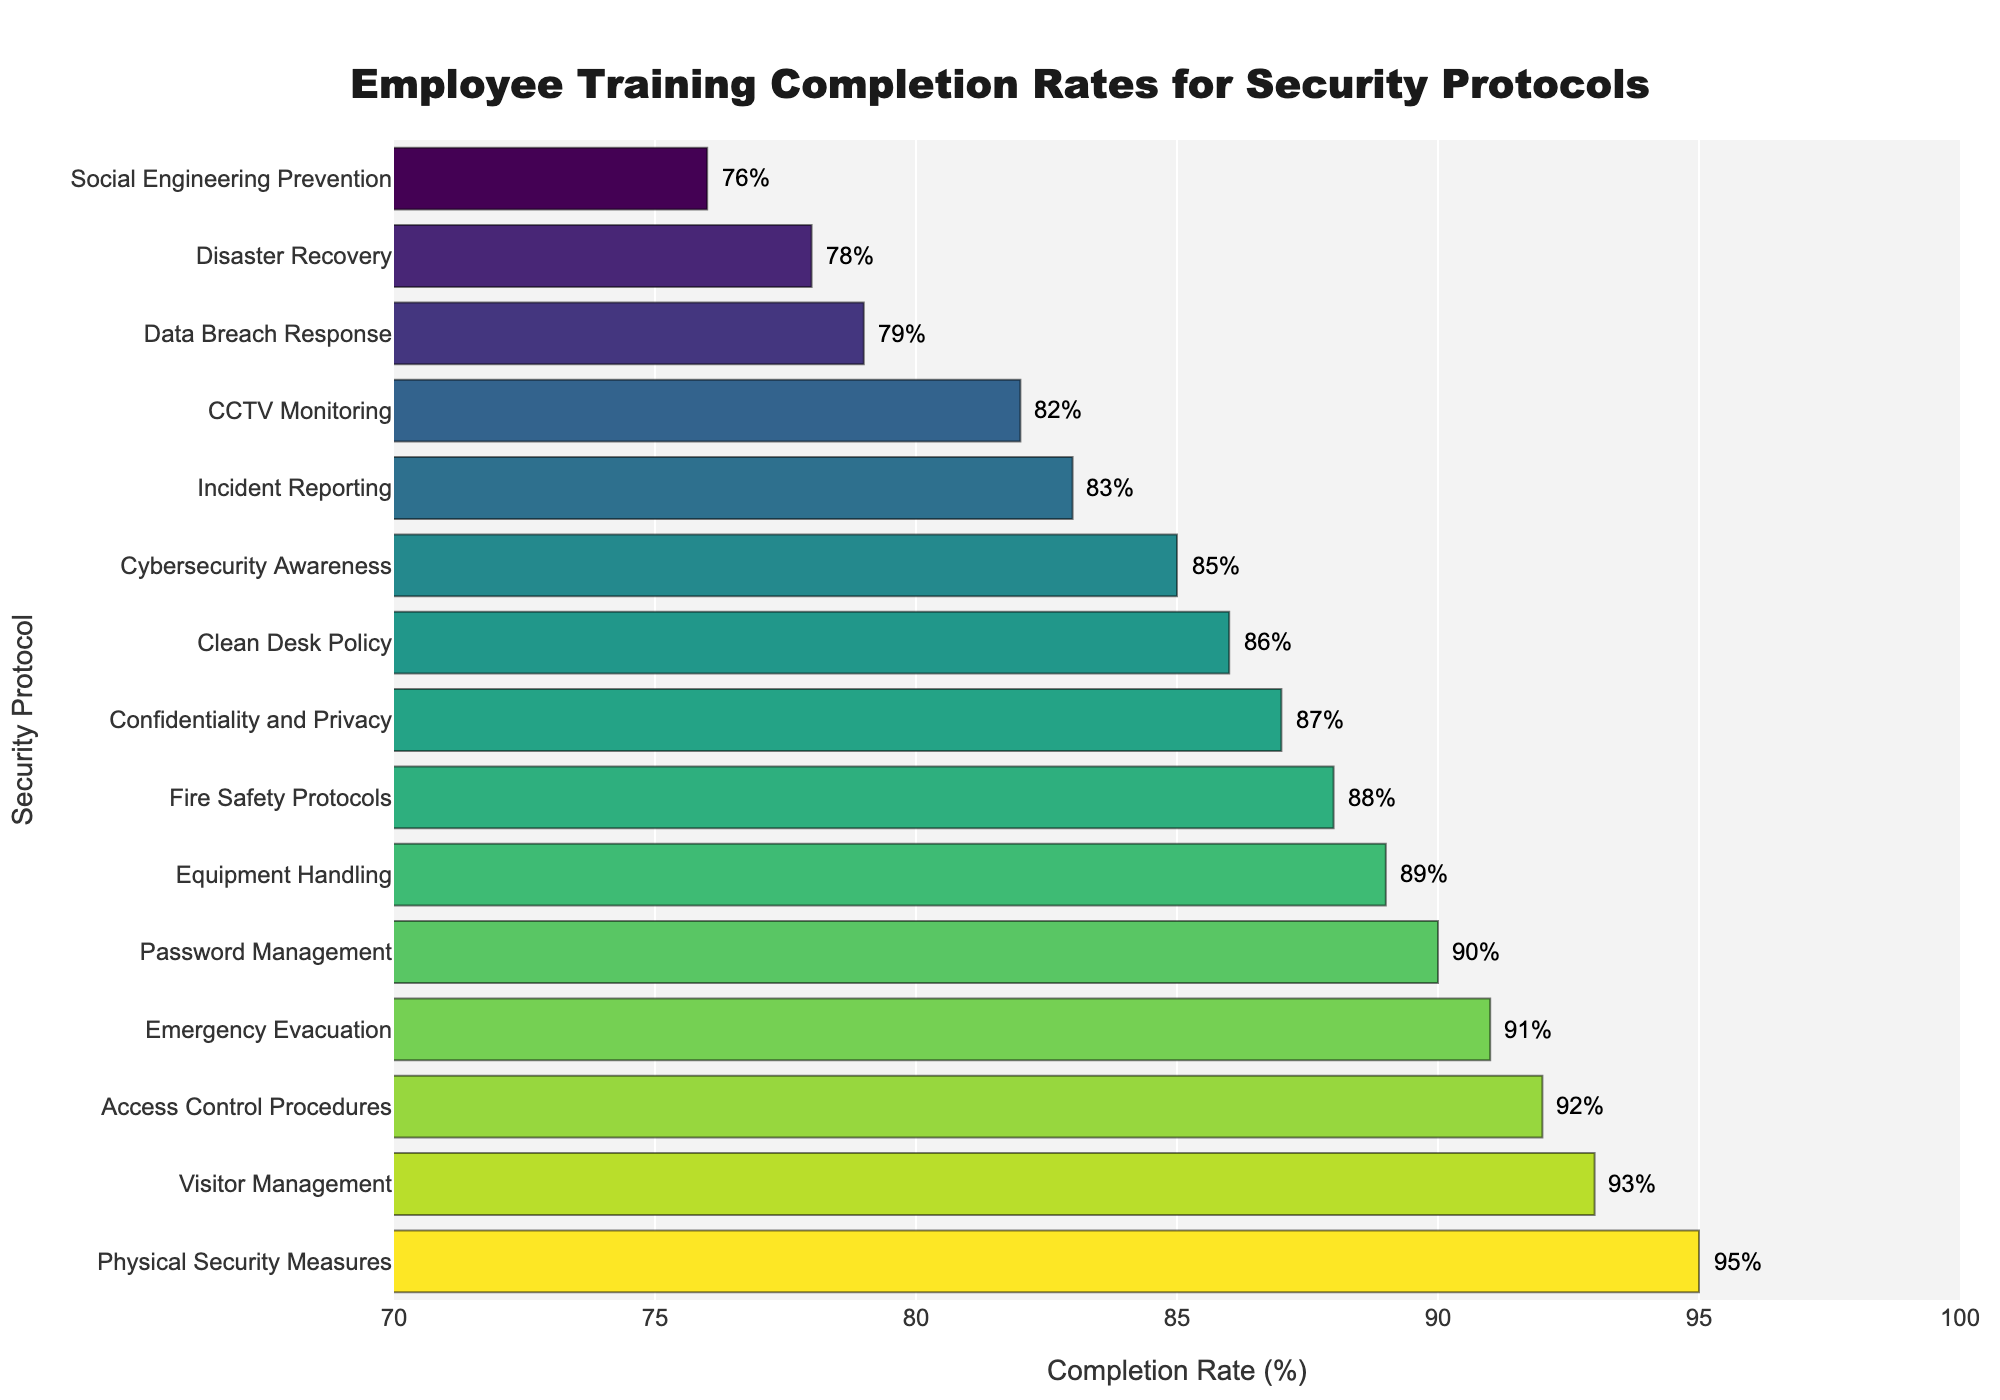What's the completion rate for the highest completed security protocol? The bar chart shows different security protocols with their respective completion rates. The highest bar corresponds to "Physical Security Measures" with a completion rate of 95%.
Answer: 95% Which security protocol has the lowest completion rate? Look for the shortest bar in the chart to identify the lowest completion rate, which is "Social Engineering Prevention" at 76%.
Answer: Social Engineering Prevention What is the average completion rate across all security protocols? Sum all completion rates and divide by the number of protocols. The rates are: [92, 88, 79, 95, 85, 91, 83, 87, 76, 89, 93, 82, 78, 86, 90]. The sum is 1244 and there are 15 protocols, so the average is 1244/15 = 82.93.
Answer: 82.93 How many security protocols have a completion rate above 90%? Identify and count the bars with a completion rate higher than 90%. These are "Access Control Procedures", "Physical Security Measures", "Emergency Evacuation", "Visitor Management", and "Password Management", making it 5 protocols.
Answer: 5 What is the difference between the highest and lowest completion rates? Subtract the lowest completion rate (76% for "Social Engineering Prevention") from the highest (95% for "Physical Security Measures"). The difference is 95 - 76 = 19.
Answer: 19 Which protocols have a completion rate between 80% and 90%? Look for bars that fall within the 80-90% range. These are "Fire Safety Protocols" (88%), "Data Breach Response" (79%), "Cybersecurity Awareness" (85%), "Incident Reporting" (83%), "Confidentiality and Privacy" (87%), "CCTV Monitoring" (82%), and "Clean Desk Policy" (86%).
Answer: Fire Safety Protocols, Cybersecurity Awareness, Incident Reporting, Confidentiality and Privacy, CCTV Monitoring, Clean Desk Policy What is the median completion rate of the training protocols? Sort the completion rates in ascending order and find the middle value. Sorted rates: [76, 78, 79, 82, 83, 85, 86, 87, 88, 89, 90, 91, 92, 93, 95]. The median (middle value) is 87.
Answer: 87 Compare the completion rates for "Data Breach Response" and "Password Management." Which one is higher? Locate both bars for "Data Breach Response" (79%) and "Password Management" (90%). Observe that the bar for "Password Management" is higher.
Answer: Password Management Which protocol shows a completion rate closest to the average rate of all protocols? The average completion rate is 82.93%. Compare this with individual rates. The closest is 83% for "Incident Reporting."
Answer: Incident Reporting How many protocols have a completion rate below 85%? Identify and count the bars with a completion rate below 85%. These are "Data Breach Response" (79%), "Social Engineering Prevention" (76%), "CCTV Monitoring" (82%), "Disaster Recovery" (78%), and "Incident Reporting" (83%), making it 5 protocols.
Answer: 5 